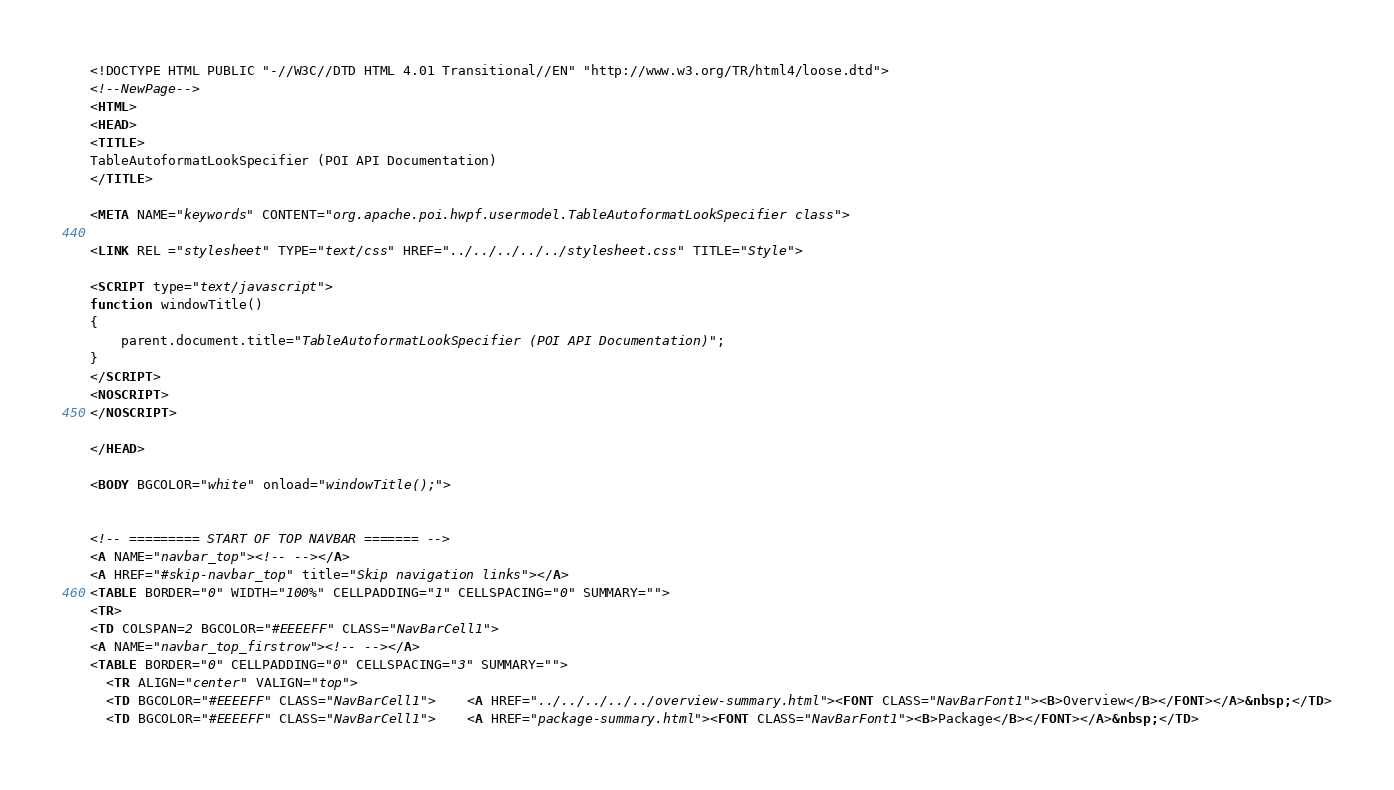<code> <loc_0><loc_0><loc_500><loc_500><_HTML_><!DOCTYPE HTML PUBLIC "-//W3C//DTD HTML 4.01 Transitional//EN" "http://www.w3.org/TR/html4/loose.dtd">
<!--NewPage-->
<HTML>
<HEAD>
<TITLE>
TableAutoformatLookSpecifier (POI API Documentation)
</TITLE>

<META NAME="keywords" CONTENT="org.apache.poi.hwpf.usermodel.TableAutoformatLookSpecifier class">

<LINK REL ="stylesheet" TYPE="text/css" HREF="../../../../../stylesheet.css" TITLE="Style">

<SCRIPT type="text/javascript">
function windowTitle()
{
    parent.document.title="TableAutoformatLookSpecifier (POI API Documentation)";
}
</SCRIPT>
<NOSCRIPT>
</NOSCRIPT>

</HEAD>

<BODY BGCOLOR="white" onload="windowTitle();">


<!-- ========= START OF TOP NAVBAR ======= -->
<A NAME="navbar_top"><!-- --></A>
<A HREF="#skip-navbar_top" title="Skip navigation links"></A>
<TABLE BORDER="0" WIDTH="100%" CELLPADDING="1" CELLSPACING="0" SUMMARY="">
<TR>
<TD COLSPAN=2 BGCOLOR="#EEEEFF" CLASS="NavBarCell1">
<A NAME="navbar_top_firstrow"><!-- --></A>
<TABLE BORDER="0" CELLPADDING="0" CELLSPACING="3" SUMMARY="">
  <TR ALIGN="center" VALIGN="top">
  <TD BGCOLOR="#EEEEFF" CLASS="NavBarCell1">    <A HREF="../../../../../overview-summary.html"><FONT CLASS="NavBarFont1"><B>Overview</B></FONT></A>&nbsp;</TD>
  <TD BGCOLOR="#EEEEFF" CLASS="NavBarCell1">    <A HREF="package-summary.html"><FONT CLASS="NavBarFont1"><B>Package</B></FONT></A>&nbsp;</TD></code> 